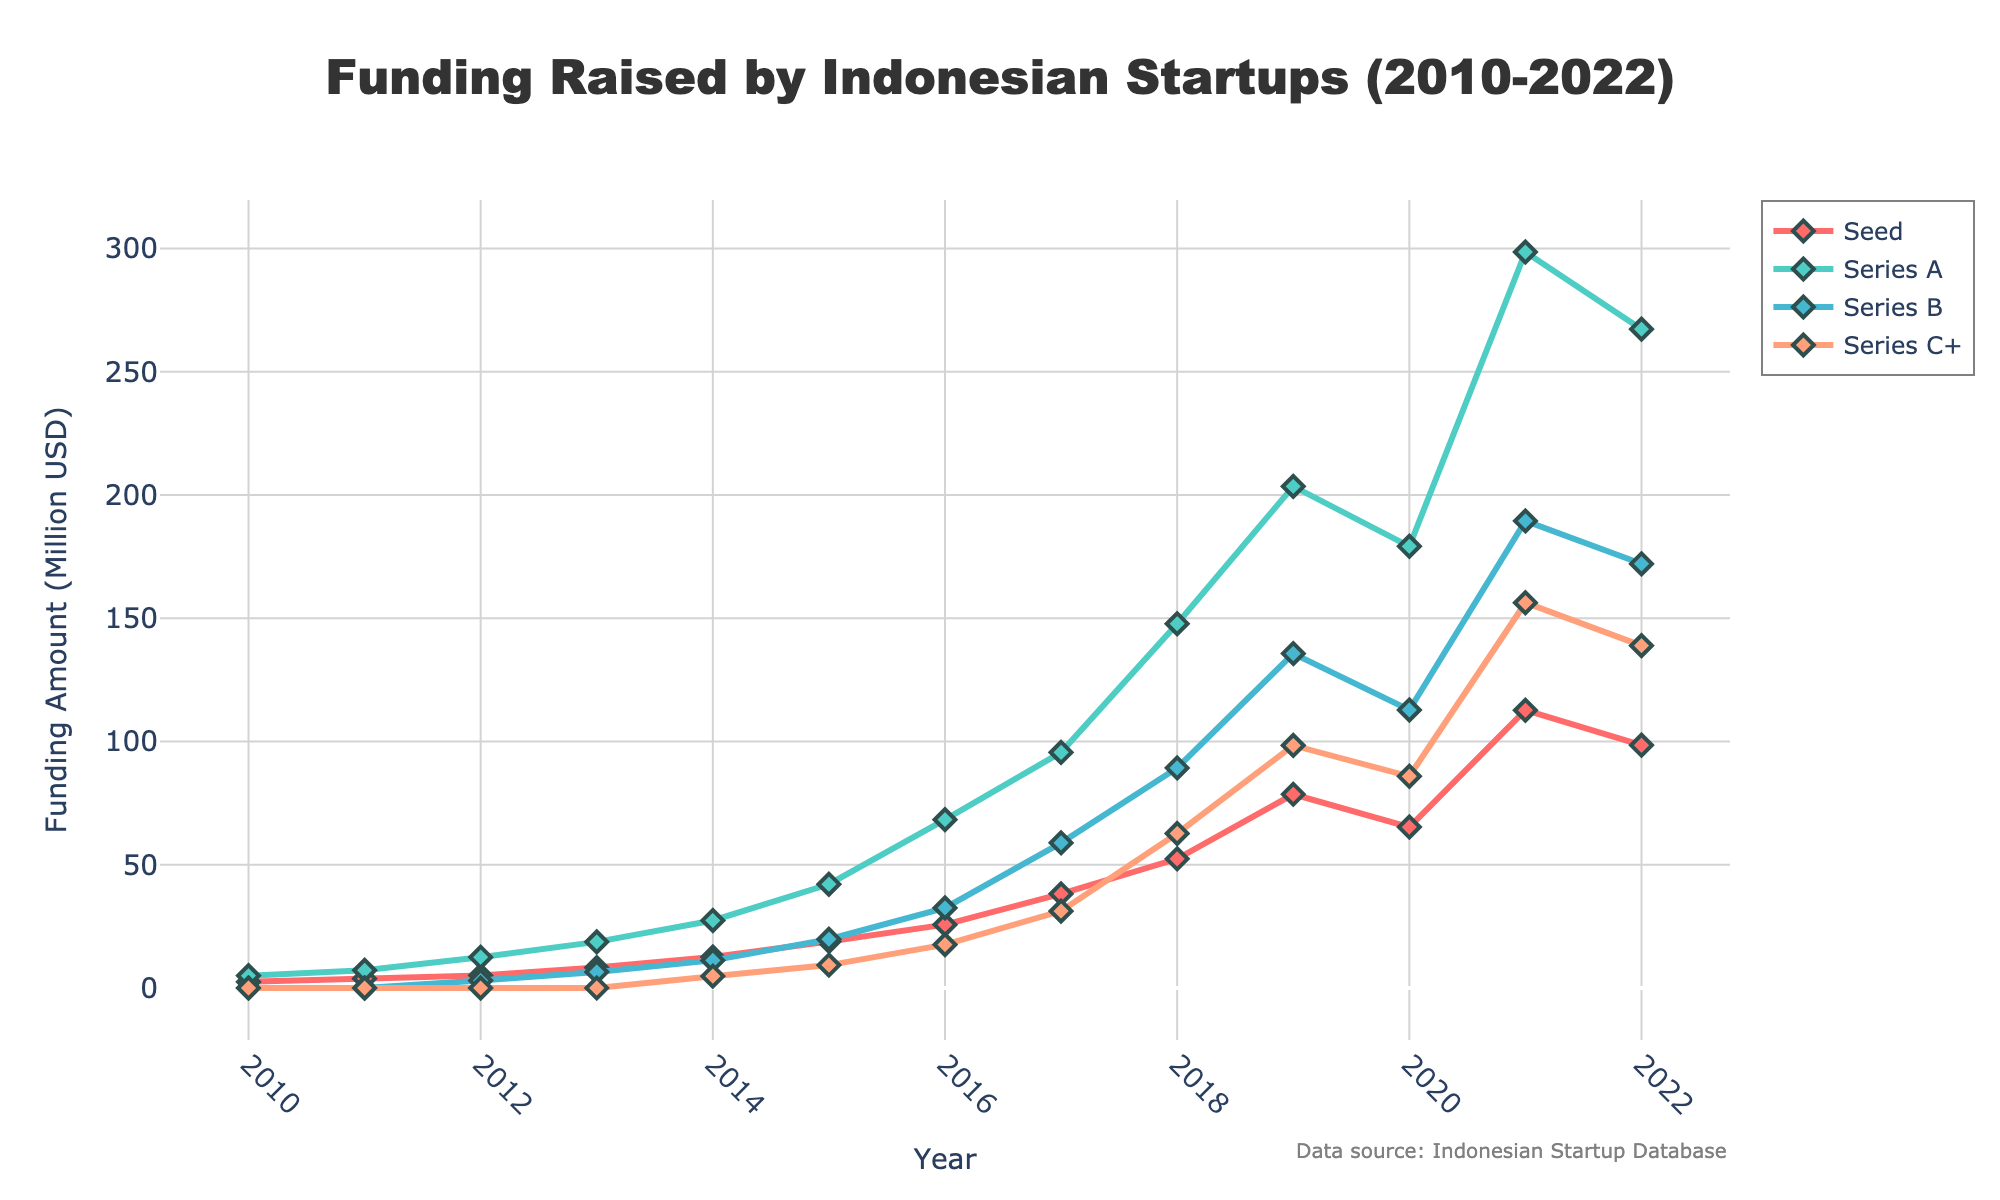What year had the highest funding amount in the Seed stage? By observing the line representing the Seed stage (in red), the highest point occurs at 2021.
Answer: 2021 Between 2014 and 2018, how much did the Series A funding increase? In 2014, Series A funding was 27.4 million USD, and in 2018 it was 147.8 million USD. The increase can be calculated as 147.8 - 27.4 = 120.4 million USD.
Answer: 120.4 million USD Compare Series B and Series C+ funding in 2020. Which was higher? In 2020, Series B funding was 112.8 million USD, and Series C+ funding was 85.9 million USD. Series B was higher.
Answer: Series B What is the average funding amount for Series A from 2010 to 2015? Sum the Series A funding from 2010 to 2015 (5.0 + 7.2 + 12.5 + 18.7 + 27.4 + 42.1 = 112.9) and divide by the number of years (6). The average is 112.9 / 6 = 18.82 million USD.
Answer: 18.82 million USD Which funding stage showed the most significant growth rate between 2012 and 2017? Calculate the growth rate for each stage from 2012 to 2017. Seed: (38.2 - 5.1) / 5.1 = 6.49, Series A: (95.6 - 12.5) / 12.5 = 6.65, Series B: (58.9 - 3.0) / 3.0 = 18.63, Series C+: (31.2 - 0) / 1 = ∞, but considering finite initial values, Series B shows the highest rate relative to its initial amount.
Answer: Series B How did the Series C+ funding amount change from 2019 to 2020? The funding amount for Series C+ in 2019 was 98.4 million USD, and in 2020 it was 85.9 million USD. The change is 85.9 - 98.4 = -12.5 million USD, indicating a decrease.
Answer: Decreased by 12.5 million USD Which visual attribute denotes the Series B funding amounts? The Series B funding amounts are denoted by a blue line with diamond markers.
Answer: Blue line In which year did the Series A funding first surpass 100 million USD? The Series A funding first surpassed 100 million USD in 2018.
Answer: 2018 